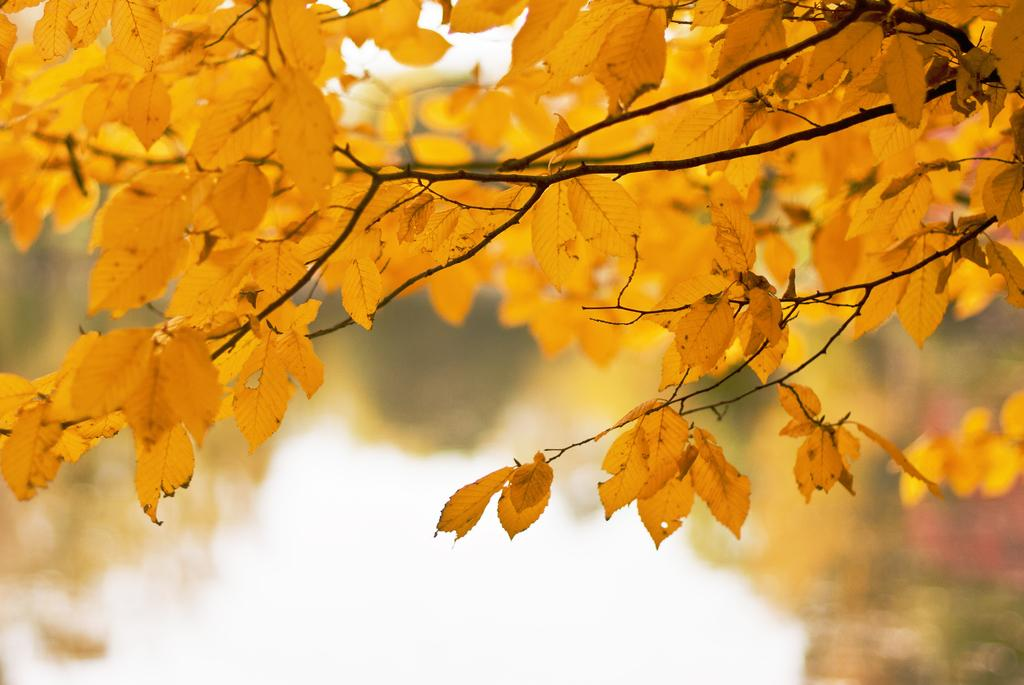What color are the leaves on the tree branch in the image? The leaves on the tree branch in the image are yellow. How is the background of the leaves depicted in the image? The background of the leaves is blurred in the image. Can you see a snail wearing a vest on the tree branch in the image? There is no snail or vest present on the tree branch in the image. 